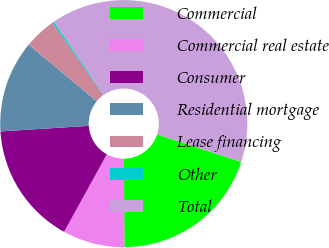Convert chart. <chart><loc_0><loc_0><loc_500><loc_500><pie_chart><fcel>Commercial<fcel>Commercial real estate<fcel>Consumer<fcel>Residential mortgage<fcel>Lease financing<fcel>Other<fcel>Total<nl><fcel>19.91%<fcel>8.1%<fcel>15.97%<fcel>12.04%<fcel>4.17%<fcel>0.24%<fcel>39.57%<nl></chart> 